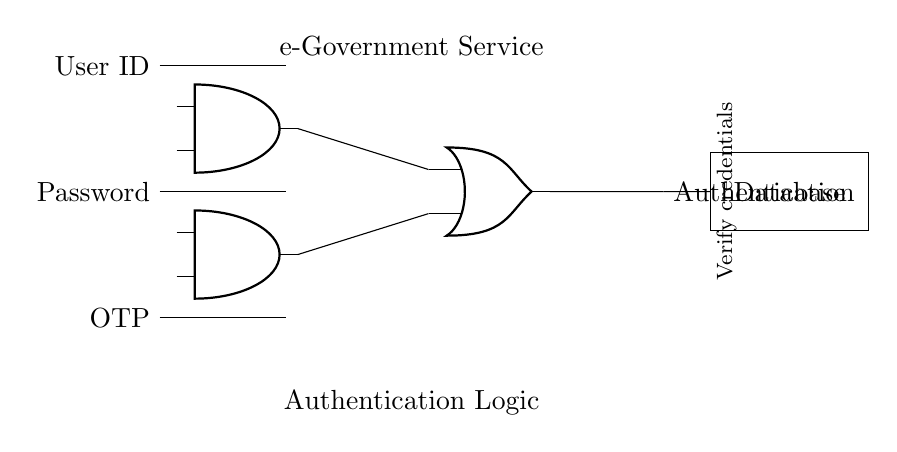What inputs are required for authentication? The circuit requires three inputs: User ID, Password, and OTP, as indicated by the labeled lines entering the diagram.
Answer: User ID, Password, OTP How many AND gates are present in this circuit? The circuit has two AND gates, as shown by the two 'and port' symbols in the diagram at defined coordinates.
Answer: Two What is the purpose of the OR gate in this circuit? The OR gate combines the outputs of the two AND gates, allowing for successful authentication if either condition is true, which makes it crucial for dual-factor authentication.
Answer: Combine authentication signals How many outputs does the circuit have? The circuit has one output, which is the authentication signal leading to the database, as shown by the single output line connected to the database component.
Answer: One What is the function of the database in the circuit? The database's role is to verify the credentials received through the authentication signal, ensuring whether the user is authenticated against stored data.
Answer: Verify credentials What does the text labeled "e-Government Service" represent? The text indicates the overall context of the circuit, which relates to its application in providing digital services for government initiatives, essential for user access to government services.
Answer: e-Government Service What verification mechanism is implied by the circuit design? The design implies a multi-factor authentication mechanism, as it requires multiple inputs (User ID, Password, OTP) for successful authentication, enhancing security for e-government services.
Answer: Multi-factor authentication 